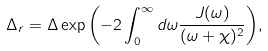<formula> <loc_0><loc_0><loc_500><loc_500>\Delta _ { r } = \Delta \exp { \left ( - 2 \int _ { 0 } ^ { \infty } d \omega \frac { J ( \omega ) } { ( \omega + \chi ) ^ { 2 } } \right ) } ,</formula> 